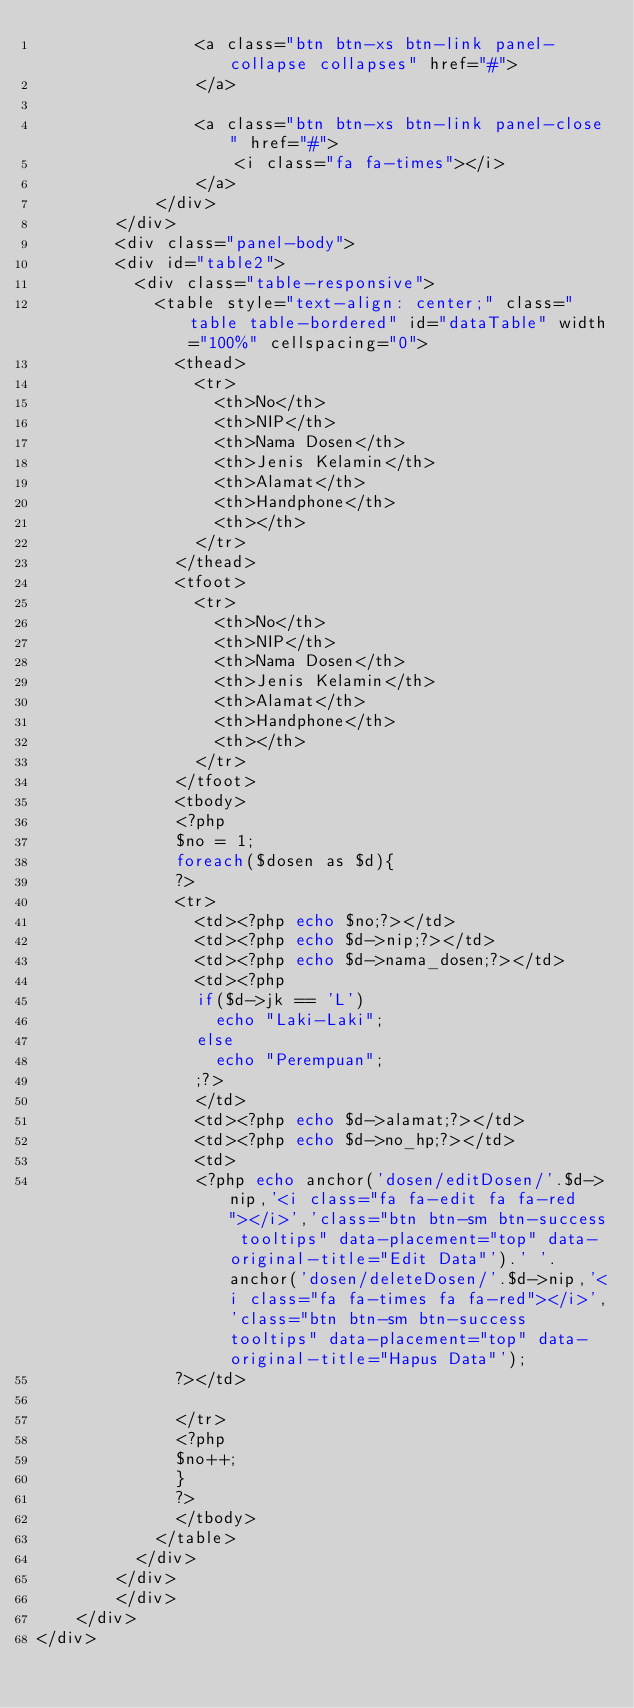<code> <loc_0><loc_0><loc_500><loc_500><_PHP_>                <a class="btn btn-xs btn-link panel-collapse collapses" href="#">
                </a>

                <a class="btn btn-xs btn-link panel-close" href="#">
                    <i class="fa fa-times"></i>
                </a>
            </div>
        </div>
        <div class="panel-body">
        <div id="table2">
          <div class="table-responsive">
            <table style="text-align: center;" class="table table-bordered" id="dataTable" width="100%" cellspacing="0">
              <thead>
                <tr>
                  <th>No</th>
                  <th>NIP</th>
                  <th>Nama Dosen</th>
                  <th>Jenis Kelamin</th>
                  <th>Alamat</th>
                  <th>Handphone</th>
                  <th></th>
                </tr>
              </thead>
              <tfoot>
                <tr>
                  <th>No</th>
                  <th>NIP</th>
                  <th>Nama Dosen</th>
                  <th>Jenis Kelamin</th>
                  <th>Alamat</th>
                  <th>Handphone</th>
                  <th></th>
                </tr>
              </tfoot>              
              <tbody>
              <?php
              $no = 1;
              foreach($dosen as $d){
              ?>
              <tr>
                <td><?php echo $no;?></td>
                <td><?php echo $d->nip;?></td>
                <td><?php echo $d->nama_dosen;?></td>
                <td><?php 
                if($d->jk == 'L')
                  echo "Laki-Laki";
                else
                  echo "Perempuan";
                ;?>
                </td>
                <td><?php echo $d->alamat;?></td>
                <td><?php echo $d->no_hp;?></td>
                <td>
                <?php echo anchor('dosen/editDosen/'.$d->nip,'<i class="fa fa-edit fa fa-red"></i>','class="btn btn-sm btn-success tooltips" data-placement="top" data-original-title="Edit Data"').' '.anchor('dosen/deleteDosen/'.$d->nip,'<i class="fa fa-times fa fa-red"></i>','class="btn btn-sm btn-success tooltips" data-placement="top" data-original-title="Hapus Data"');
              ?></td>

              </tr>
              <?php
              $no++;
              }
              ?>
              </tbody>
            </table>  
          </div>         
        </div>   
        </div>
    </div>
</div>



</code> 